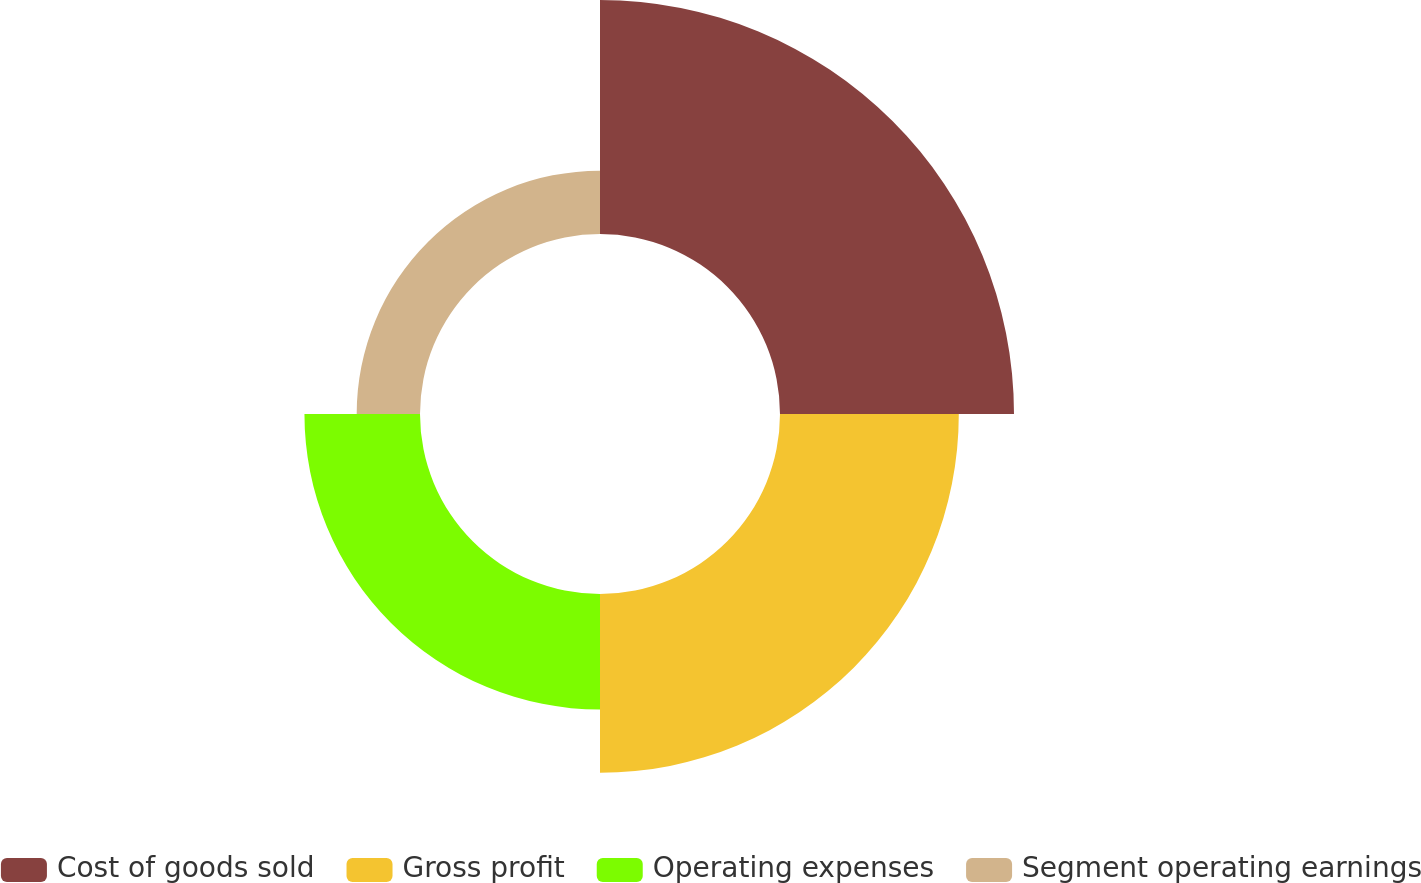<chart> <loc_0><loc_0><loc_500><loc_500><pie_chart><fcel>Cost of goods sold<fcel>Gross profit<fcel>Operating expenses<fcel>Segment operating earnings<nl><fcel>39.55%<fcel>30.22%<fcel>19.53%<fcel>10.7%<nl></chart> 